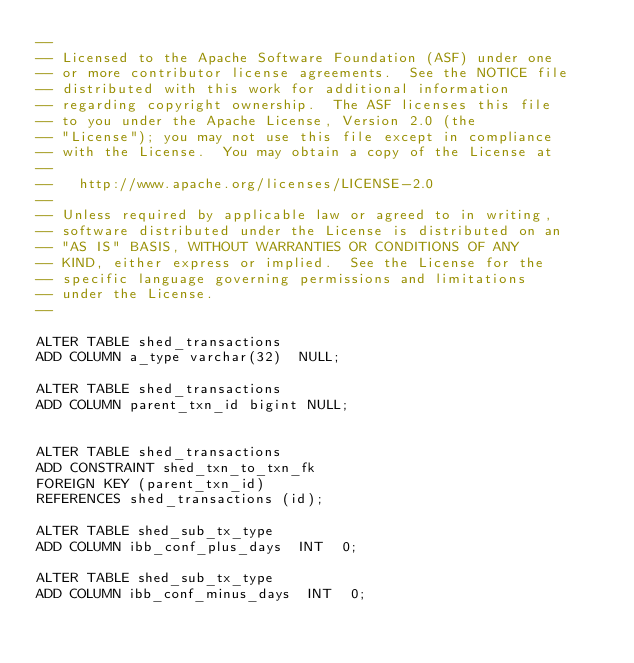Convert code to text. <code><loc_0><loc_0><loc_500><loc_500><_SQL_>--
-- Licensed to the Apache Software Foundation (ASF) under one
-- or more contributor license agreements.  See the NOTICE file
-- distributed with this work for additional information
-- regarding copyright ownership.  The ASF licenses this file
-- to you under the Apache License, Version 2.0 (the
-- "License"); you may not use this file except in compliance
-- with the License.  You may obtain a copy of the License at
--
--   http://www.apache.org/licenses/LICENSE-2.0
--
-- Unless required by applicable law or agreed to in writing,
-- software distributed under the License is distributed on an
-- "AS IS" BASIS, WITHOUT WARRANTIES OR CONDITIONS OF ANY
-- KIND, either express or implied.  See the License for the
-- specific language governing permissions and limitations
-- under the License.
--

ALTER TABLE shed_transactions
ADD COLUMN a_type varchar(32)  NULL;

ALTER TABLE shed_transactions
ADD COLUMN parent_txn_id bigint NULL;


ALTER TABLE shed_transactions
ADD CONSTRAINT shed_txn_to_txn_fk
FOREIGN KEY (parent_txn_id)
REFERENCES shed_transactions (id);

ALTER TABLE shed_sub_tx_type
ADD COLUMN ibb_conf_plus_days  INT  0;

ALTER TABLE shed_sub_tx_type
ADD COLUMN ibb_conf_minus_days  INT  0;</code> 